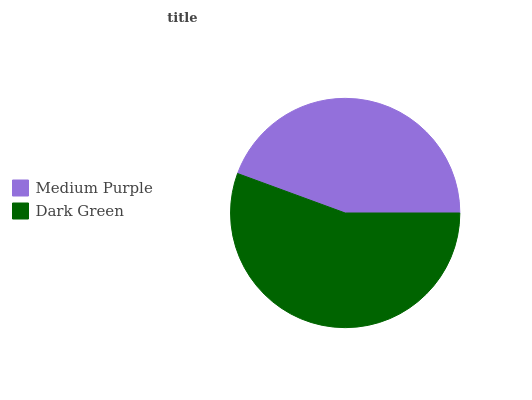Is Medium Purple the minimum?
Answer yes or no. Yes. Is Dark Green the maximum?
Answer yes or no. Yes. Is Dark Green the minimum?
Answer yes or no. No. Is Dark Green greater than Medium Purple?
Answer yes or no. Yes. Is Medium Purple less than Dark Green?
Answer yes or no. Yes. Is Medium Purple greater than Dark Green?
Answer yes or no. No. Is Dark Green less than Medium Purple?
Answer yes or no. No. Is Dark Green the high median?
Answer yes or no. Yes. Is Medium Purple the low median?
Answer yes or no. Yes. Is Medium Purple the high median?
Answer yes or no. No. Is Dark Green the low median?
Answer yes or no. No. 